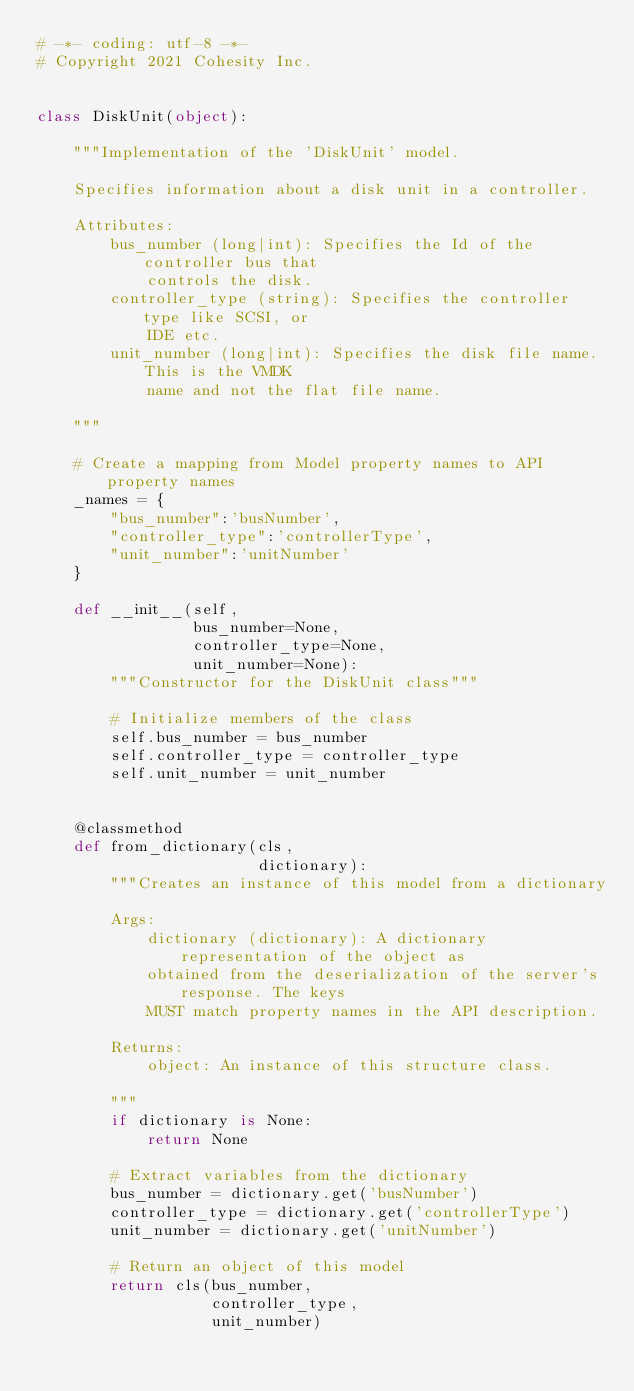<code> <loc_0><loc_0><loc_500><loc_500><_Python_># -*- coding: utf-8 -*-
# Copyright 2021 Cohesity Inc.


class DiskUnit(object):

    """Implementation of the 'DiskUnit' model.

    Specifies information about a disk unit in a controller.

    Attributes:
        bus_number (long|int): Specifies the Id of the controller bus that
            controls the disk.
        controller_type (string): Specifies the controller type like SCSI, or
            IDE etc.
        unit_number (long|int): Specifies the disk file name. This is the VMDK
            name and not the flat file name.

    """

    # Create a mapping from Model property names to API property names
    _names = {
        "bus_number":'busNumber',
        "controller_type":'controllerType',
        "unit_number":'unitNumber'
    }

    def __init__(self,
                 bus_number=None,
                 controller_type=None,
                 unit_number=None):
        """Constructor for the DiskUnit class"""

        # Initialize members of the class
        self.bus_number = bus_number
        self.controller_type = controller_type
        self.unit_number = unit_number


    @classmethod
    def from_dictionary(cls,
                        dictionary):
        """Creates an instance of this model from a dictionary

        Args:
            dictionary (dictionary): A dictionary representation of the object as
            obtained from the deserialization of the server's response. The keys
            MUST match property names in the API description.

        Returns:
            object: An instance of this structure class.

        """
        if dictionary is None:
            return None

        # Extract variables from the dictionary
        bus_number = dictionary.get('busNumber')
        controller_type = dictionary.get('controllerType')
        unit_number = dictionary.get('unitNumber')

        # Return an object of this model
        return cls(bus_number,
                   controller_type,
                   unit_number)


</code> 